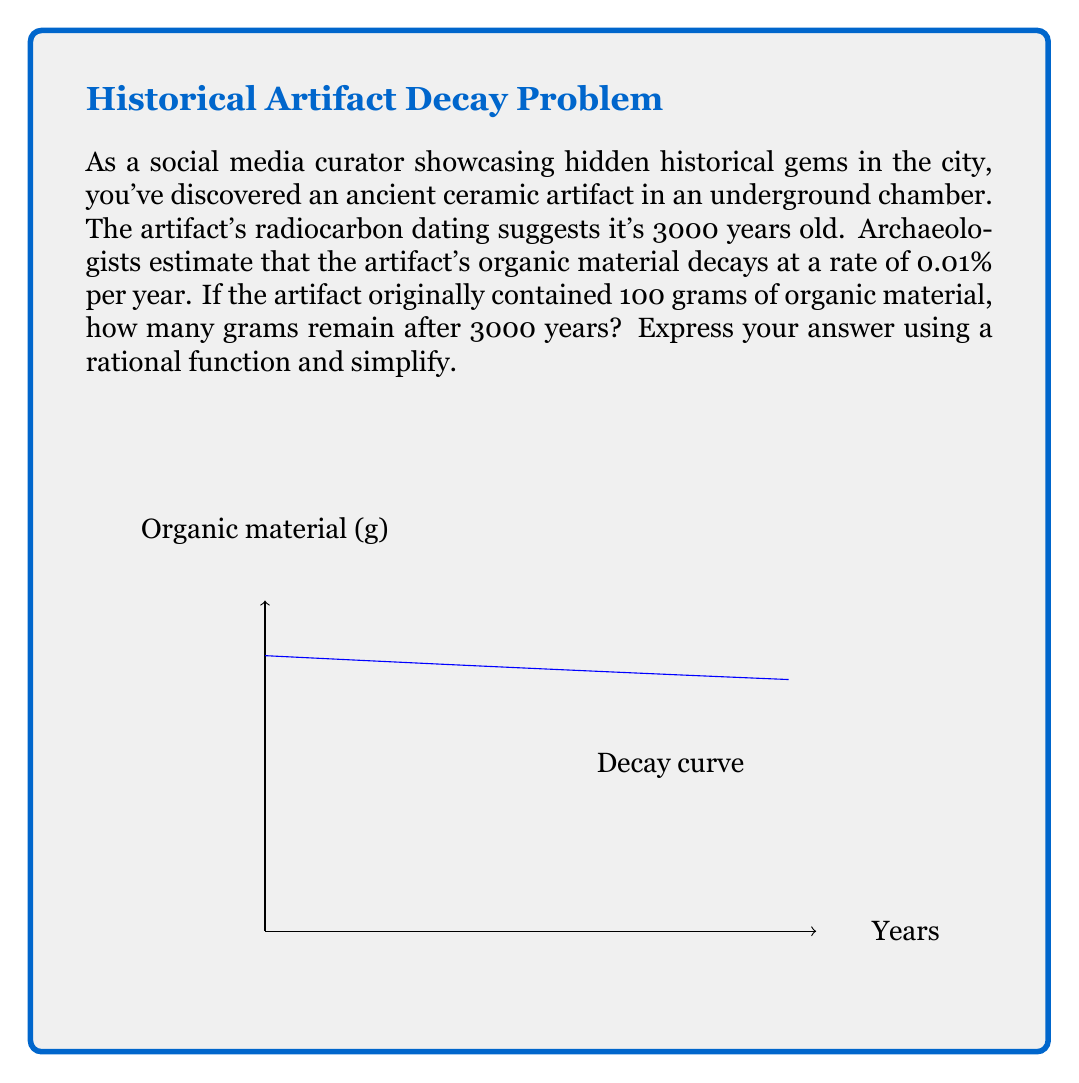Help me with this question. Let's approach this step-by-step:

1) The decay rate is 0.01% = 0.0001 per year.

2) Let $x$ be the number of years passed and $y$ be the amount of organic material remaining.

3) The general form of a rational function for decay is:

   $$y = \frac{a}{1 + bx}$$

   where $a$ is the initial amount and $b$ is the decay rate.

4) Substituting our values:

   $$y = \frac{100}{1 + 0.0001x}$$

5) To find the amount remaining after 3000 years, we substitute $x = 3000$:

   $$y = \frac{100}{1 + 0.0001(3000)}$$

6) Simplify:
   
   $$y = \frac{100}{1 + 0.3} = \frac{100}{1.3}$$

7) Calculate:
   
   $$y = 76.92307692...$$

8) Rounding to two decimal places:

   $$y \approx 76.92\text{ grams}$$
Answer: $\frac{100}{1.3} \approx 76.92\text{ grams}$ 